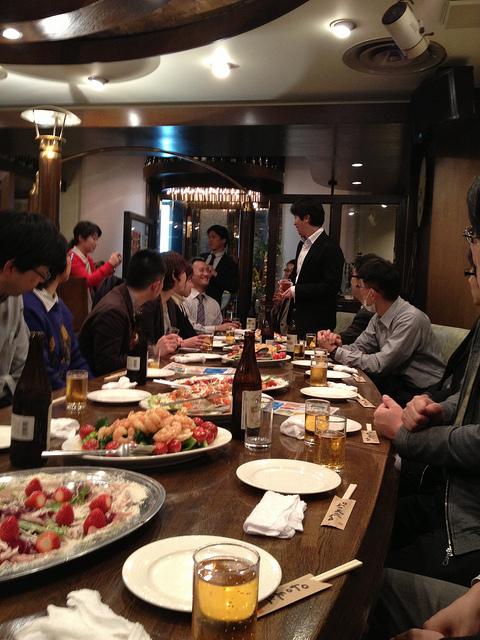What type of place is this?
Quick response, please. Restaurant. Are there several people seated at this table?
Short answer required. Yes. Has everyone started eating?
Short answer required. No. What type of food is being served?
Give a very brief answer. Seafood. 